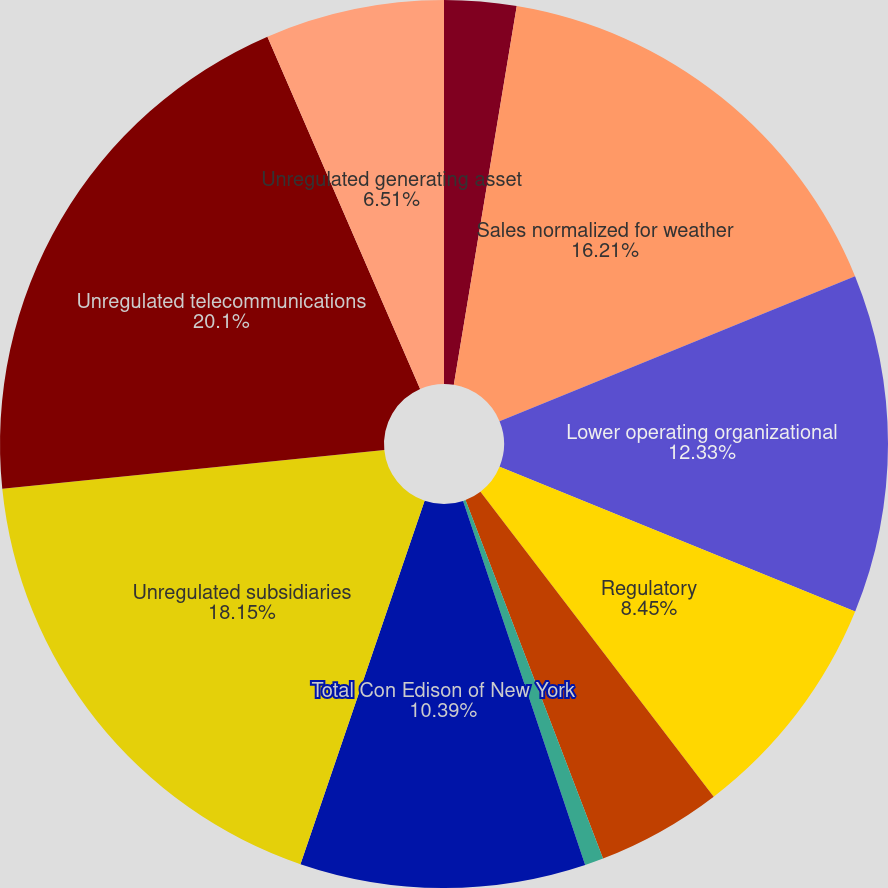Convert chart. <chart><loc_0><loc_0><loc_500><loc_500><pie_chart><fcel>Impact of weather in 2003 on<fcel>Sales normalized for weather<fcel>Lower operating organizational<fcel>Regulatory<fcel>Lower sales and use tax<fcel>Other<fcel>Total Con Edison of New York<fcel>Unregulated subsidiaries<fcel>Unregulated telecommunications<fcel>Unregulated generating asset<nl><fcel>2.62%<fcel>16.21%<fcel>12.33%<fcel>8.45%<fcel>4.56%<fcel>0.68%<fcel>10.39%<fcel>18.15%<fcel>20.1%<fcel>6.51%<nl></chart> 